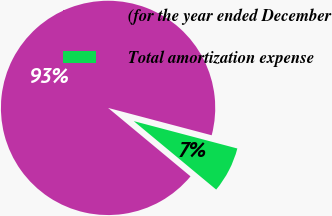<chart> <loc_0><loc_0><loc_500><loc_500><pie_chart><fcel>(for the year ended December<fcel>Total amortization expense<nl><fcel>93.08%<fcel>6.92%<nl></chart> 